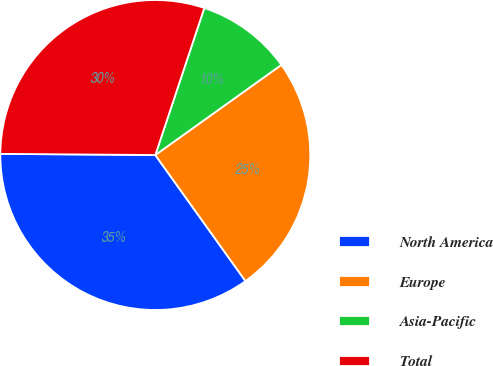Convert chart to OTSL. <chart><loc_0><loc_0><loc_500><loc_500><pie_chart><fcel>North America<fcel>Europe<fcel>Asia-Pacific<fcel>Total<nl><fcel>35.0%<fcel>25.0%<fcel>10.0%<fcel>30.0%<nl></chart> 